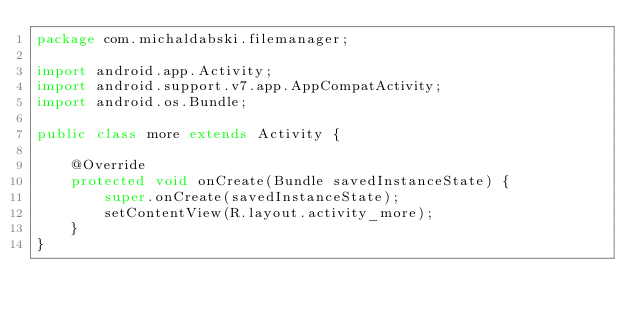<code> <loc_0><loc_0><loc_500><loc_500><_Java_>package com.michaldabski.filemanager;

import android.app.Activity;
import android.support.v7.app.AppCompatActivity;
import android.os.Bundle;

public class more extends Activity {

    @Override
    protected void onCreate(Bundle savedInstanceState) {
        super.onCreate(savedInstanceState);
        setContentView(R.layout.activity_more);
    }
}</code> 